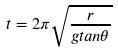<formula> <loc_0><loc_0><loc_500><loc_500>t = 2 \pi \sqrt { \frac { r } { g t a n \theta } }</formula> 